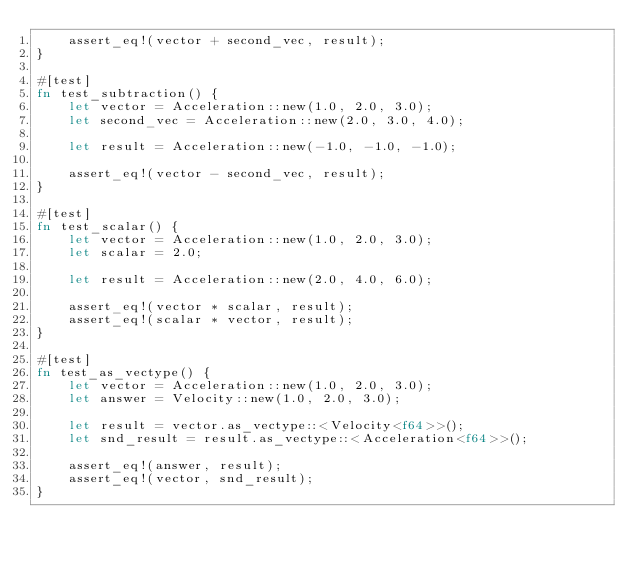<code> <loc_0><loc_0><loc_500><loc_500><_Rust_>    assert_eq!(vector + second_vec, result);
}

#[test]
fn test_subtraction() {
    let vector = Acceleration::new(1.0, 2.0, 3.0);
    let second_vec = Acceleration::new(2.0, 3.0, 4.0);

    let result = Acceleration::new(-1.0, -1.0, -1.0);

    assert_eq!(vector - second_vec, result);
}

#[test]
fn test_scalar() {
    let vector = Acceleration::new(1.0, 2.0, 3.0);
    let scalar = 2.0;

    let result = Acceleration::new(2.0, 4.0, 6.0);

    assert_eq!(vector * scalar, result);
    assert_eq!(scalar * vector, result);
}

#[test]
fn test_as_vectype() {
    let vector = Acceleration::new(1.0, 2.0, 3.0);
    let answer = Velocity::new(1.0, 2.0, 3.0);

    let result = vector.as_vectype::<Velocity<f64>>();
    let snd_result = result.as_vectype::<Acceleration<f64>>();

    assert_eq!(answer, result);
    assert_eq!(vector, snd_result);
}
</code> 